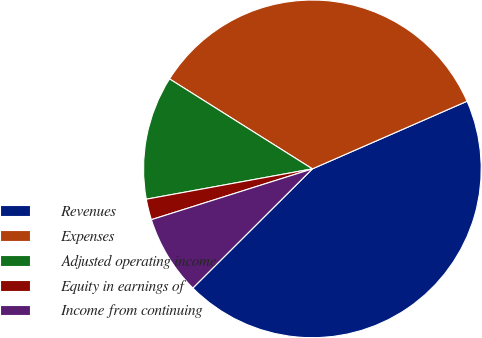<chart> <loc_0><loc_0><loc_500><loc_500><pie_chart><fcel>Revenues<fcel>Expenses<fcel>Adjusted operating income<fcel>Equity in earnings of<fcel>Income from continuing<nl><fcel>44.09%<fcel>34.5%<fcel>11.82%<fcel>1.99%<fcel>7.61%<nl></chart> 